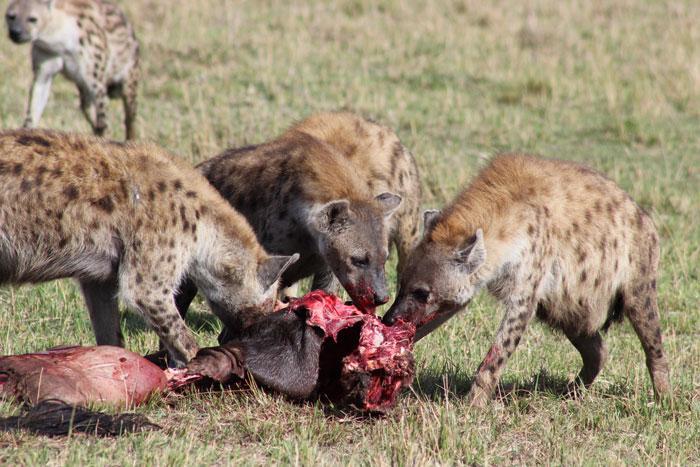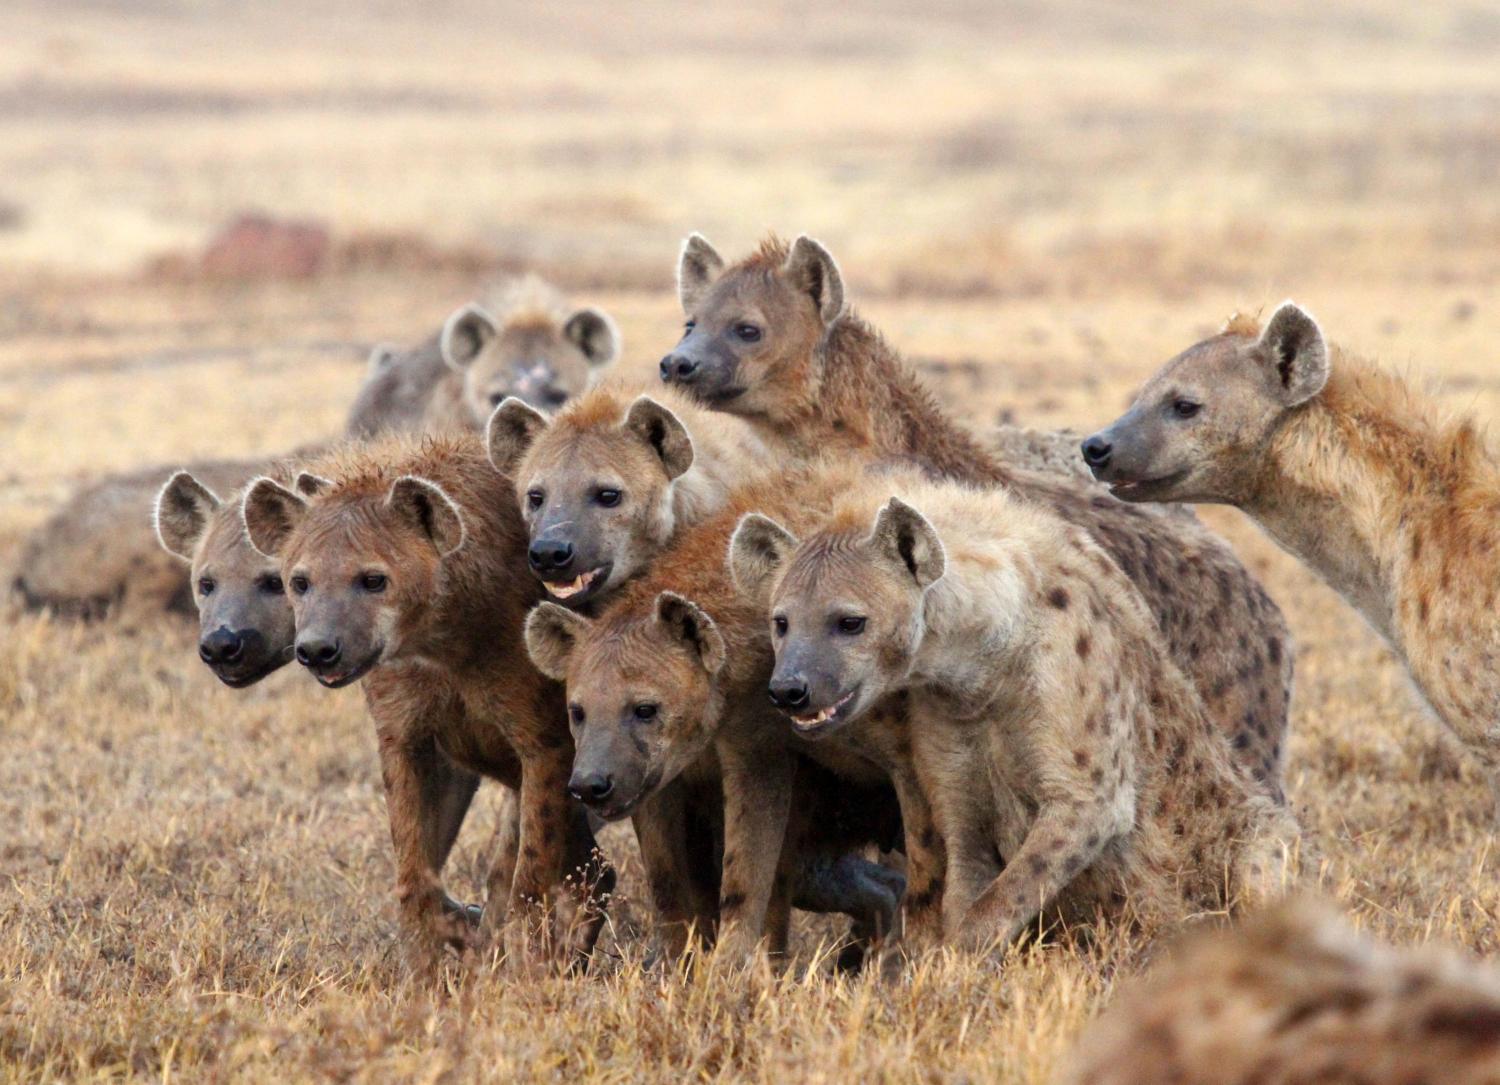The first image is the image on the left, the second image is the image on the right. Evaluate the accuracy of this statement regarding the images: "Some of the animals are eating their prey.". Is it true? Answer yes or no. Yes. The first image is the image on the left, the second image is the image on the right. Considering the images on both sides, is "At least one image shows hyenas around an animal carcass." valid? Answer yes or no. Yes. 